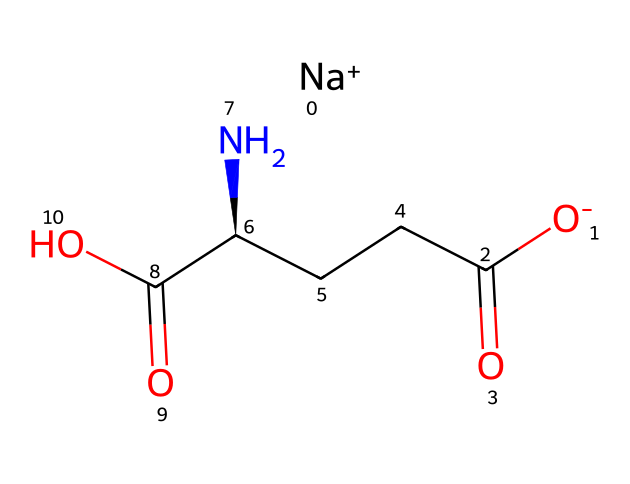What is the chemical formula of monosodium glutamate? The SMILES representation indicates the presence of one sodium ion (Na) and the organic part consists of glutamic acid, represented by the carbon (C) atoms and functional groups (amino and carboxyl). Collectively, the components lead to the formula of C5H8N1O4Na.
Answer: C5H8N1O4Na How many carbon atoms are in monosodium glutamate? By analyzing the structure in the SMILES, we identify five carbon (C) atoms. Each carbon atom is represented in the carbon backbone of the glutamate structure.
Answer: 5 What functional groups are present in monosodium glutamate? The structure includes one carboxyl group (-COOH), which is characteristic of glutamic acid, and an amine group (-NH2). These groups are crucial for the properties of MSG.
Answer: carboxyl and amine What role does sodium (Na) play in monosodium glutamate? The sodium ion (Na+) is present as a counter ion that balances the negative charge from the glutamate structure, enabling it to function as a sodium salt of glutamic acid.
Answer: balancing negative charge Is monosodium glutamate hydrophilic or hydrophobic? The presence of polar functional groups like the carboxyl and amino groups indicates that monosodium glutamate is soluble in water, making it hydrophilic.
Answer: hydrophilic How many nitrogen atoms are in monosodium glutamate? Observing the SMILES representation, there is one nitrogen (N) atom associated with the amine (-NH2) group in the structure, confirming that there is a single nitrogen atom.
Answer: 1 Does monosodium glutamate contain any double bonds? The structure shows double bonds present in the carbonyl groups (C=O) within the carboxyl groups of glutamic acid. This indicates that the molecule is unsaturated regarding those bonds.
Answer: yes 